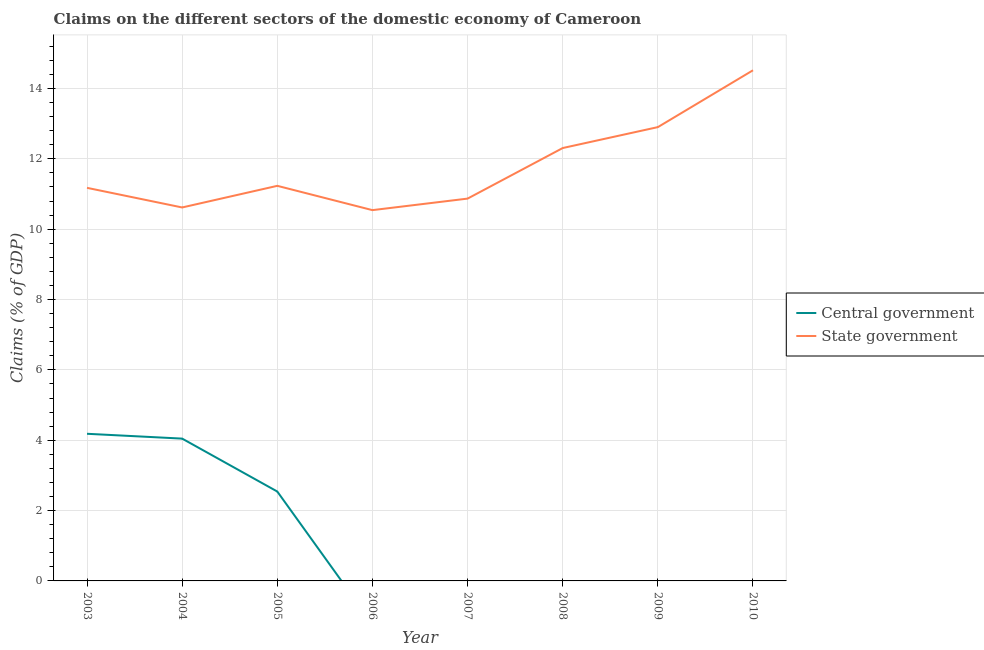How many different coloured lines are there?
Your answer should be very brief. 2. Does the line corresponding to claims on state government intersect with the line corresponding to claims on central government?
Your response must be concise. No. Is the number of lines equal to the number of legend labels?
Your response must be concise. No. What is the claims on central government in 2009?
Ensure brevity in your answer.  0. Across all years, what is the maximum claims on central government?
Ensure brevity in your answer.  4.18. Across all years, what is the minimum claims on state government?
Provide a short and direct response. 10.54. In which year was the claims on state government maximum?
Offer a very short reply. 2010. What is the total claims on central government in the graph?
Provide a succinct answer. 10.77. What is the difference between the claims on state government in 2006 and that in 2009?
Make the answer very short. -2.36. What is the difference between the claims on central government in 2006 and the claims on state government in 2010?
Provide a short and direct response. -14.52. What is the average claims on state government per year?
Offer a very short reply. 11.77. In the year 2005, what is the difference between the claims on state government and claims on central government?
Keep it short and to the point. 8.69. In how many years, is the claims on state government greater than 2 %?
Your response must be concise. 8. What is the ratio of the claims on central government in 2004 to that in 2005?
Provide a succinct answer. 1.59. What is the difference between the highest and the second highest claims on state government?
Your answer should be compact. 1.62. What is the difference between the highest and the lowest claims on state government?
Ensure brevity in your answer.  3.98. In how many years, is the claims on state government greater than the average claims on state government taken over all years?
Provide a short and direct response. 3. Is the sum of the claims on state government in 2003 and 2006 greater than the maximum claims on central government across all years?
Your answer should be very brief. Yes. How are the legend labels stacked?
Provide a short and direct response. Vertical. What is the title of the graph?
Keep it short and to the point. Claims on the different sectors of the domestic economy of Cameroon. Does "Formally registered" appear as one of the legend labels in the graph?
Ensure brevity in your answer.  No. What is the label or title of the Y-axis?
Your answer should be compact. Claims (% of GDP). What is the Claims (% of GDP) of Central government in 2003?
Your answer should be very brief. 4.18. What is the Claims (% of GDP) of State government in 2003?
Provide a succinct answer. 11.18. What is the Claims (% of GDP) of Central government in 2004?
Your answer should be compact. 4.05. What is the Claims (% of GDP) in State government in 2004?
Keep it short and to the point. 10.62. What is the Claims (% of GDP) in Central government in 2005?
Make the answer very short. 2.54. What is the Claims (% of GDP) of State government in 2005?
Offer a very short reply. 11.23. What is the Claims (% of GDP) in Central government in 2006?
Make the answer very short. 0. What is the Claims (% of GDP) in State government in 2006?
Your answer should be very brief. 10.54. What is the Claims (% of GDP) in Central government in 2007?
Keep it short and to the point. 0. What is the Claims (% of GDP) of State government in 2007?
Ensure brevity in your answer.  10.87. What is the Claims (% of GDP) in Central government in 2008?
Give a very brief answer. 0. What is the Claims (% of GDP) in State government in 2008?
Provide a succinct answer. 12.31. What is the Claims (% of GDP) in State government in 2009?
Your answer should be compact. 12.9. What is the Claims (% of GDP) in Central government in 2010?
Ensure brevity in your answer.  0. What is the Claims (% of GDP) in State government in 2010?
Make the answer very short. 14.52. Across all years, what is the maximum Claims (% of GDP) of Central government?
Offer a very short reply. 4.18. Across all years, what is the maximum Claims (% of GDP) in State government?
Provide a succinct answer. 14.52. Across all years, what is the minimum Claims (% of GDP) in State government?
Your answer should be compact. 10.54. What is the total Claims (% of GDP) in Central government in the graph?
Offer a very short reply. 10.77. What is the total Claims (% of GDP) of State government in the graph?
Make the answer very short. 94.16. What is the difference between the Claims (% of GDP) in Central government in 2003 and that in 2004?
Your answer should be compact. 0.14. What is the difference between the Claims (% of GDP) of State government in 2003 and that in 2004?
Your answer should be compact. 0.56. What is the difference between the Claims (% of GDP) in Central government in 2003 and that in 2005?
Make the answer very short. 1.64. What is the difference between the Claims (% of GDP) in State government in 2003 and that in 2005?
Give a very brief answer. -0.06. What is the difference between the Claims (% of GDP) in State government in 2003 and that in 2006?
Offer a very short reply. 0.63. What is the difference between the Claims (% of GDP) of State government in 2003 and that in 2007?
Provide a short and direct response. 0.31. What is the difference between the Claims (% of GDP) of State government in 2003 and that in 2008?
Keep it short and to the point. -1.13. What is the difference between the Claims (% of GDP) of State government in 2003 and that in 2009?
Offer a terse response. -1.73. What is the difference between the Claims (% of GDP) of State government in 2003 and that in 2010?
Your answer should be compact. -3.34. What is the difference between the Claims (% of GDP) of Central government in 2004 and that in 2005?
Your answer should be very brief. 1.5. What is the difference between the Claims (% of GDP) in State government in 2004 and that in 2005?
Your answer should be compact. -0.61. What is the difference between the Claims (% of GDP) of State government in 2004 and that in 2006?
Your response must be concise. 0.08. What is the difference between the Claims (% of GDP) of State government in 2004 and that in 2007?
Provide a succinct answer. -0.25. What is the difference between the Claims (% of GDP) of State government in 2004 and that in 2008?
Give a very brief answer. -1.69. What is the difference between the Claims (% of GDP) of State government in 2004 and that in 2009?
Give a very brief answer. -2.28. What is the difference between the Claims (% of GDP) in State government in 2004 and that in 2010?
Give a very brief answer. -3.9. What is the difference between the Claims (% of GDP) in State government in 2005 and that in 2006?
Your answer should be very brief. 0.69. What is the difference between the Claims (% of GDP) of State government in 2005 and that in 2007?
Ensure brevity in your answer.  0.36. What is the difference between the Claims (% of GDP) in State government in 2005 and that in 2008?
Provide a succinct answer. -1.07. What is the difference between the Claims (% of GDP) in State government in 2005 and that in 2009?
Ensure brevity in your answer.  -1.67. What is the difference between the Claims (% of GDP) in State government in 2005 and that in 2010?
Provide a short and direct response. -3.29. What is the difference between the Claims (% of GDP) of State government in 2006 and that in 2007?
Keep it short and to the point. -0.33. What is the difference between the Claims (% of GDP) in State government in 2006 and that in 2008?
Provide a succinct answer. -1.77. What is the difference between the Claims (% of GDP) in State government in 2006 and that in 2009?
Provide a succinct answer. -2.36. What is the difference between the Claims (% of GDP) of State government in 2006 and that in 2010?
Ensure brevity in your answer.  -3.98. What is the difference between the Claims (% of GDP) of State government in 2007 and that in 2008?
Your answer should be compact. -1.44. What is the difference between the Claims (% of GDP) in State government in 2007 and that in 2009?
Give a very brief answer. -2.03. What is the difference between the Claims (% of GDP) of State government in 2007 and that in 2010?
Ensure brevity in your answer.  -3.65. What is the difference between the Claims (% of GDP) of State government in 2008 and that in 2009?
Ensure brevity in your answer.  -0.59. What is the difference between the Claims (% of GDP) of State government in 2008 and that in 2010?
Keep it short and to the point. -2.21. What is the difference between the Claims (% of GDP) of State government in 2009 and that in 2010?
Your answer should be compact. -1.62. What is the difference between the Claims (% of GDP) in Central government in 2003 and the Claims (% of GDP) in State government in 2004?
Make the answer very short. -6.43. What is the difference between the Claims (% of GDP) in Central government in 2003 and the Claims (% of GDP) in State government in 2005?
Offer a terse response. -7.05. What is the difference between the Claims (% of GDP) of Central government in 2003 and the Claims (% of GDP) of State government in 2006?
Your answer should be compact. -6.36. What is the difference between the Claims (% of GDP) in Central government in 2003 and the Claims (% of GDP) in State government in 2007?
Your response must be concise. -6.69. What is the difference between the Claims (% of GDP) in Central government in 2003 and the Claims (% of GDP) in State government in 2008?
Give a very brief answer. -8.12. What is the difference between the Claims (% of GDP) of Central government in 2003 and the Claims (% of GDP) of State government in 2009?
Offer a very short reply. -8.72. What is the difference between the Claims (% of GDP) of Central government in 2003 and the Claims (% of GDP) of State government in 2010?
Keep it short and to the point. -10.33. What is the difference between the Claims (% of GDP) of Central government in 2004 and the Claims (% of GDP) of State government in 2005?
Give a very brief answer. -7.19. What is the difference between the Claims (% of GDP) of Central government in 2004 and the Claims (% of GDP) of State government in 2006?
Provide a succinct answer. -6.5. What is the difference between the Claims (% of GDP) of Central government in 2004 and the Claims (% of GDP) of State government in 2007?
Provide a short and direct response. -6.82. What is the difference between the Claims (% of GDP) in Central government in 2004 and the Claims (% of GDP) in State government in 2008?
Your answer should be very brief. -8.26. What is the difference between the Claims (% of GDP) of Central government in 2004 and the Claims (% of GDP) of State government in 2009?
Provide a short and direct response. -8.86. What is the difference between the Claims (% of GDP) of Central government in 2004 and the Claims (% of GDP) of State government in 2010?
Make the answer very short. -10.47. What is the difference between the Claims (% of GDP) of Central government in 2005 and the Claims (% of GDP) of State government in 2006?
Your answer should be very brief. -8. What is the difference between the Claims (% of GDP) in Central government in 2005 and the Claims (% of GDP) in State government in 2007?
Offer a very short reply. -8.33. What is the difference between the Claims (% of GDP) of Central government in 2005 and the Claims (% of GDP) of State government in 2008?
Provide a short and direct response. -9.77. What is the difference between the Claims (% of GDP) of Central government in 2005 and the Claims (% of GDP) of State government in 2009?
Provide a short and direct response. -10.36. What is the difference between the Claims (% of GDP) of Central government in 2005 and the Claims (% of GDP) of State government in 2010?
Your answer should be compact. -11.98. What is the average Claims (% of GDP) of Central government per year?
Your response must be concise. 1.35. What is the average Claims (% of GDP) in State government per year?
Give a very brief answer. 11.77. In the year 2003, what is the difference between the Claims (% of GDP) of Central government and Claims (% of GDP) of State government?
Offer a terse response. -6.99. In the year 2004, what is the difference between the Claims (% of GDP) in Central government and Claims (% of GDP) in State government?
Give a very brief answer. -6.57. In the year 2005, what is the difference between the Claims (% of GDP) of Central government and Claims (% of GDP) of State government?
Give a very brief answer. -8.69. What is the ratio of the Claims (% of GDP) in Central government in 2003 to that in 2004?
Your answer should be very brief. 1.03. What is the ratio of the Claims (% of GDP) of State government in 2003 to that in 2004?
Give a very brief answer. 1.05. What is the ratio of the Claims (% of GDP) of Central government in 2003 to that in 2005?
Keep it short and to the point. 1.65. What is the ratio of the Claims (% of GDP) of State government in 2003 to that in 2005?
Provide a succinct answer. 0.99. What is the ratio of the Claims (% of GDP) of State government in 2003 to that in 2006?
Keep it short and to the point. 1.06. What is the ratio of the Claims (% of GDP) in State government in 2003 to that in 2007?
Ensure brevity in your answer.  1.03. What is the ratio of the Claims (% of GDP) of State government in 2003 to that in 2008?
Keep it short and to the point. 0.91. What is the ratio of the Claims (% of GDP) of State government in 2003 to that in 2009?
Keep it short and to the point. 0.87. What is the ratio of the Claims (% of GDP) of State government in 2003 to that in 2010?
Provide a succinct answer. 0.77. What is the ratio of the Claims (% of GDP) of Central government in 2004 to that in 2005?
Offer a very short reply. 1.59. What is the ratio of the Claims (% of GDP) of State government in 2004 to that in 2005?
Offer a terse response. 0.95. What is the ratio of the Claims (% of GDP) in State government in 2004 to that in 2007?
Offer a very short reply. 0.98. What is the ratio of the Claims (% of GDP) of State government in 2004 to that in 2008?
Your response must be concise. 0.86. What is the ratio of the Claims (% of GDP) in State government in 2004 to that in 2009?
Provide a succinct answer. 0.82. What is the ratio of the Claims (% of GDP) of State government in 2004 to that in 2010?
Ensure brevity in your answer.  0.73. What is the ratio of the Claims (% of GDP) in State government in 2005 to that in 2006?
Give a very brief answer. 1.07. What is the ratio of the Claims (% of GDP) of State government in 2005 to that in 2007?
Keep it short and to the point. 1.03. What is the ratio of the Claims (% of GDP) of State government in 2005 to that in 2008?
Ensure brevity in your answer.  0.91. What is the ratio of the Claims (% of GDP) of State government in 2005 to that in 2009?
Your response must be concise. 0.87. What is the ratio of the Claims (% of GDP) of State government in 2005 to that in 2010?
Your answer should be compact. 0.77. What is the ratio of the Claims (% of GDP) of State government in 2006 to that in 2007?
Your response must be concise. 0.97. What is the ratio of the Claims (% of GDP) of State government in 2006 to that in 2008?
Offer a terse response. 0.86. What is the ratio of the Claims (% of GDP) in State government in 2006 to that in 2009?
Provide a short and direct response. 0.82. What is the ratio of the Claims (% of GDP) of State government in 2006 to that in 2010?
Offer a very short reply. 0.73. What is the ratio of the Claims (% of GDP) in State government in 2007 to that in 2008?
Provide a short and direct response. 0.88. What is the ratio of the Claims (% of GDP) of State government in 2007 to that in 2009?
Give a very brief answer. 0.84. What is the ratio of the Claims (% of GDP) of State government in 2007 to that in 2010?
Provide a succinct answer. 0.75. What is the ratio of the Claims (% of GDP) of State government in 2008 to that in 2009?
Give a very brief answer. 0.95. What is the ratio of the Claims (% of GDP) in State government in 2008 to that in 2010?
Give a very brief answer. 0.85. What is the ratio of the Claims (% of GDP) in State government in 2009 to that in 2010?
Provide a short and direct response. 0.89. What is the difference between the highest and the second highest Claims (% of GDP) in Central government?
Your response must be concise. 0.14. What is the difference between the highest and the second highest Claims (% of GDP) of State government?
Your answer should be very brief. 1.62. What is the difference between the highest and the lowest Claims (% of GDP) in Central government?
Offer a terse response. 4.18. What is the difference between the highest and the lowest Claims (% of GDP) in State government?
Offer a very short reply. 3.98. 